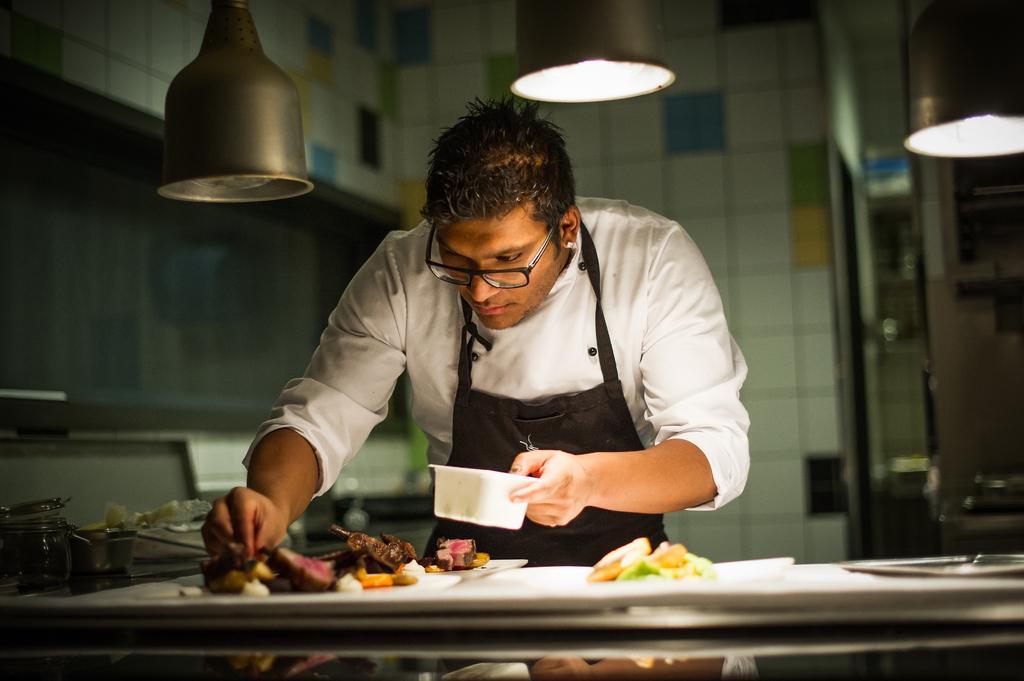Can you describe this image briefly? There is a man standing and holding bowl and we can see plates, food and some objects on table. On the background we can see wall and rod. 